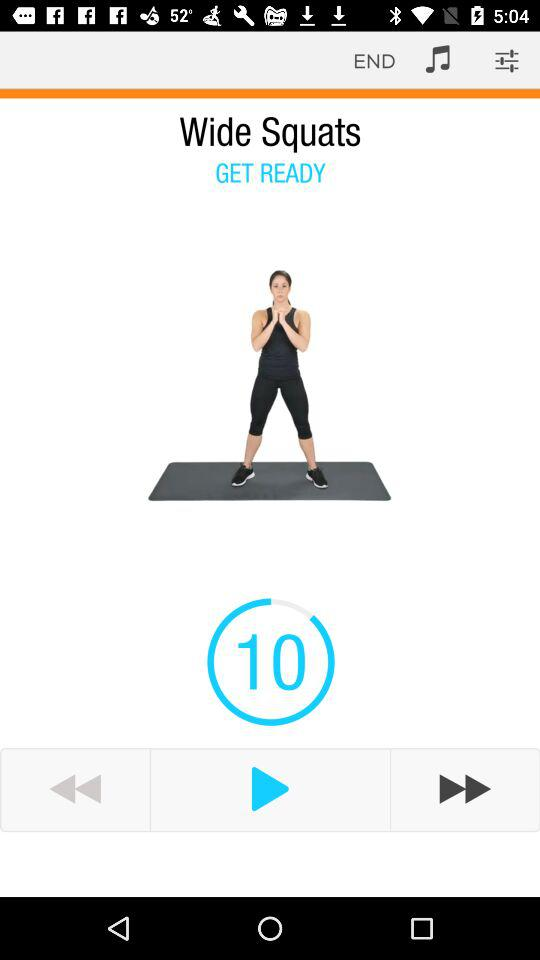What is the name of the exercise? The exercise's name is "Wide Squats". 